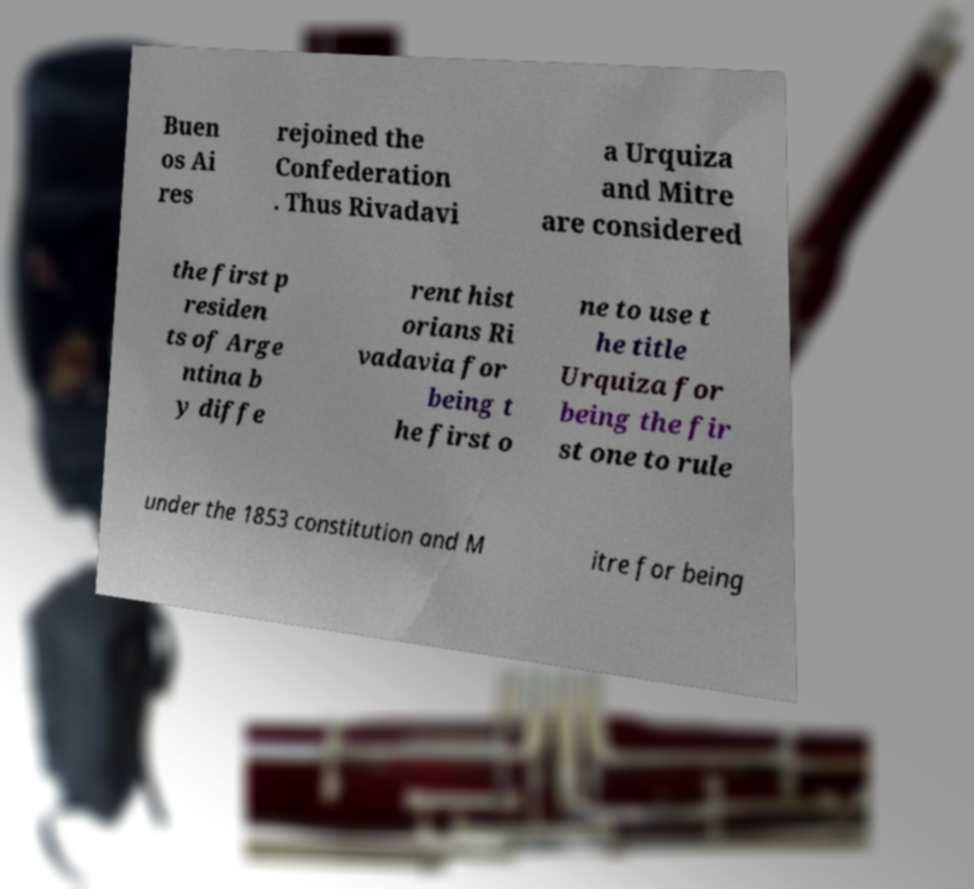Can you accurately transcribe the text from the provided image for me? Buen os Ai res rejoined the Confederation . Thus Rivadavi a Urquiza and Mitre are considered the first p residen ts of Arge ntina b y diffe rent hist orians Ri vadavia for being t he first o ne to use t he title Urquiza for being the fir st one to rule under the 1853 constitution and M itre for being 